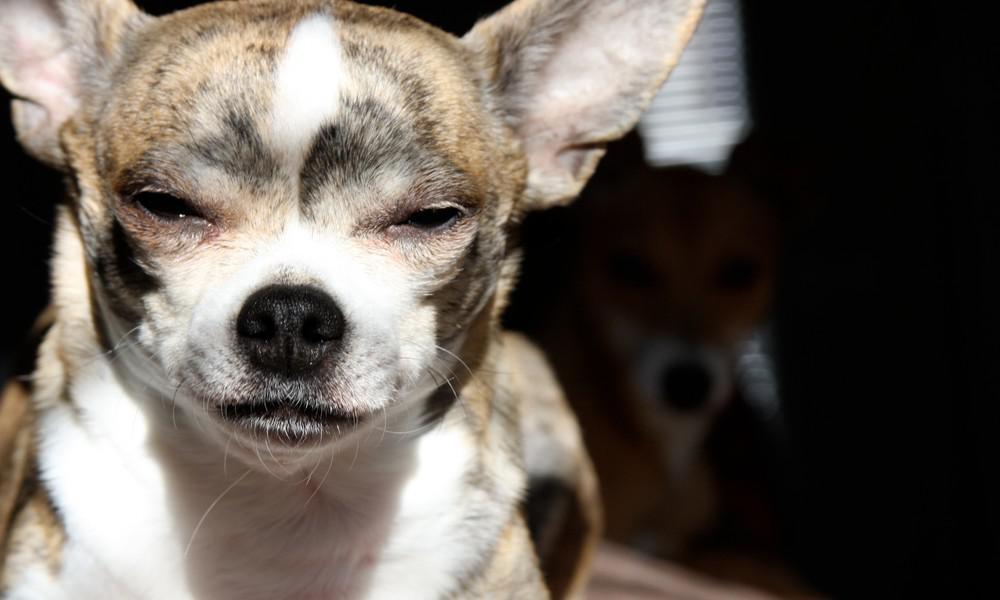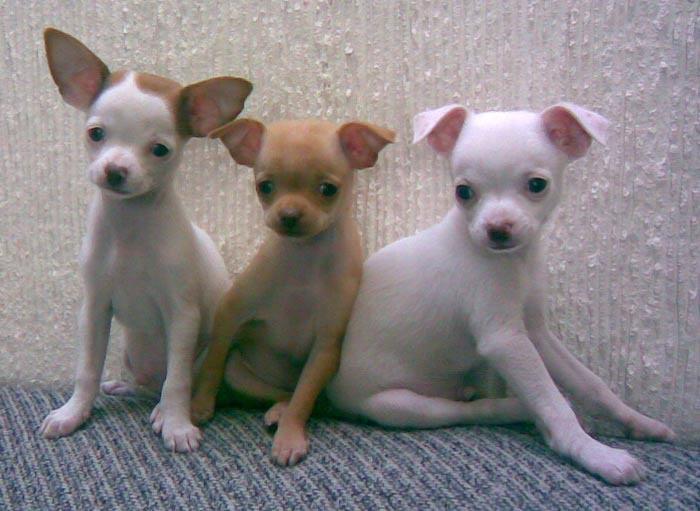The first image is the image on the left, the second image is the image on the right. For the images displayed, is the sentence "One of the dogs in one of the images is baring its teeth." factually correct? Answer yes or no. No. 